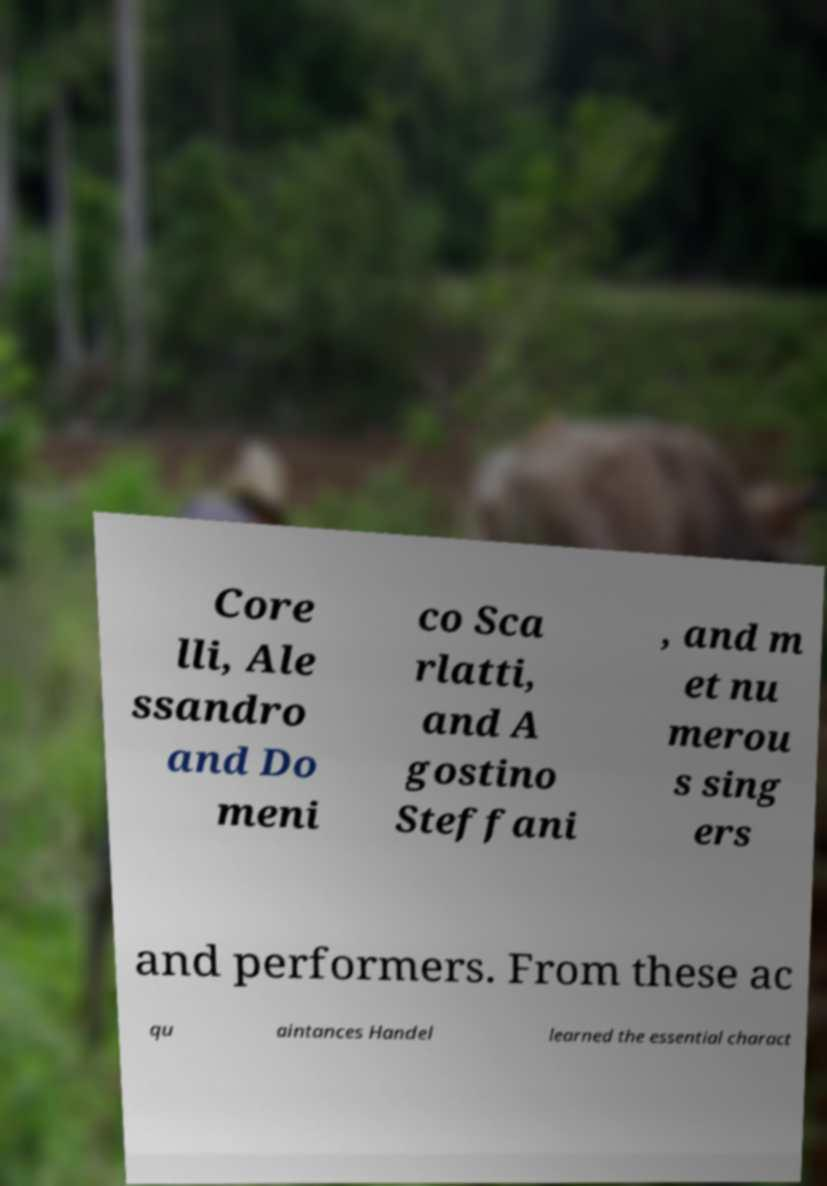What messages or text are displayed in this image? I need them in a readable, typed format. Core lli, Ale ssandro and Do meni co Sca rlatti, and A gostino Steffani , and m et nu merou s sing ers and performers. From these ac qu aintances Handel learned the essential charact 